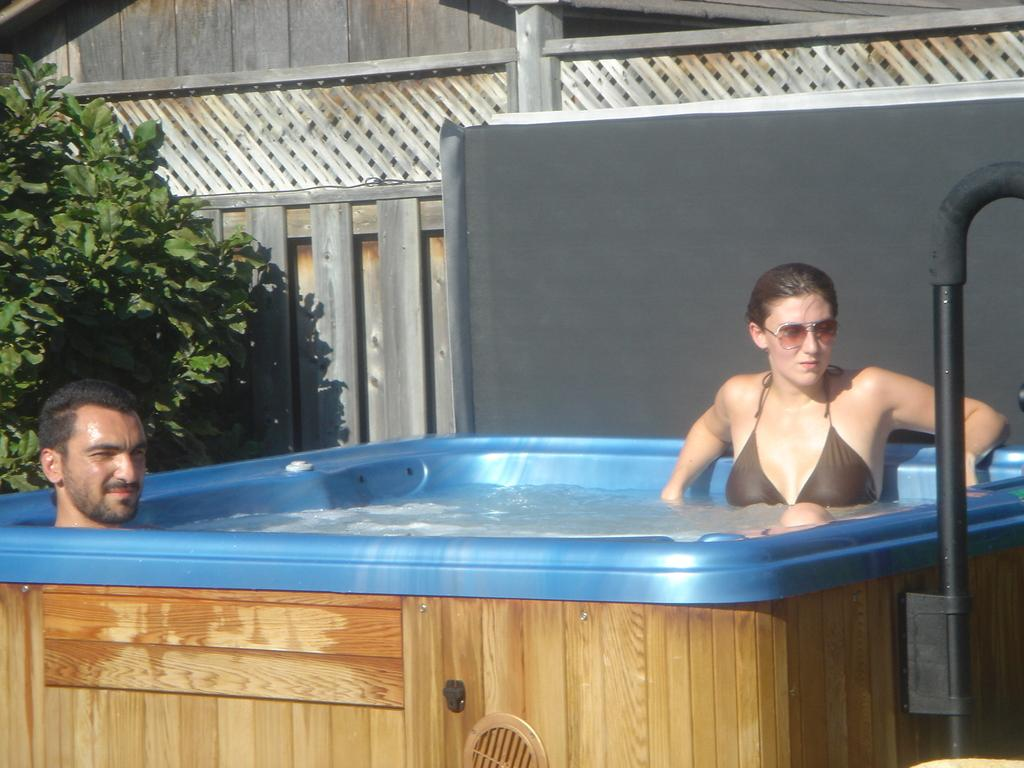How many people are in the water tub in the image? There are two persons in a water tub in the image. What can be seen in the background of the image? Plants are visible in the background of the image. What type of expansion is taking place in the image? There is no expansion taking place in the image. How does the chin of the person in the water tub look like? The image does not provide enough detail to describe the chin of the person in the water tub. 